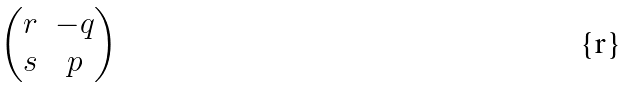<formula> <loc_0><loc_0><loc_500><loc_500>\begin{pmatrix} r & - q \\ s & p \end{pmatrix}</formula> 